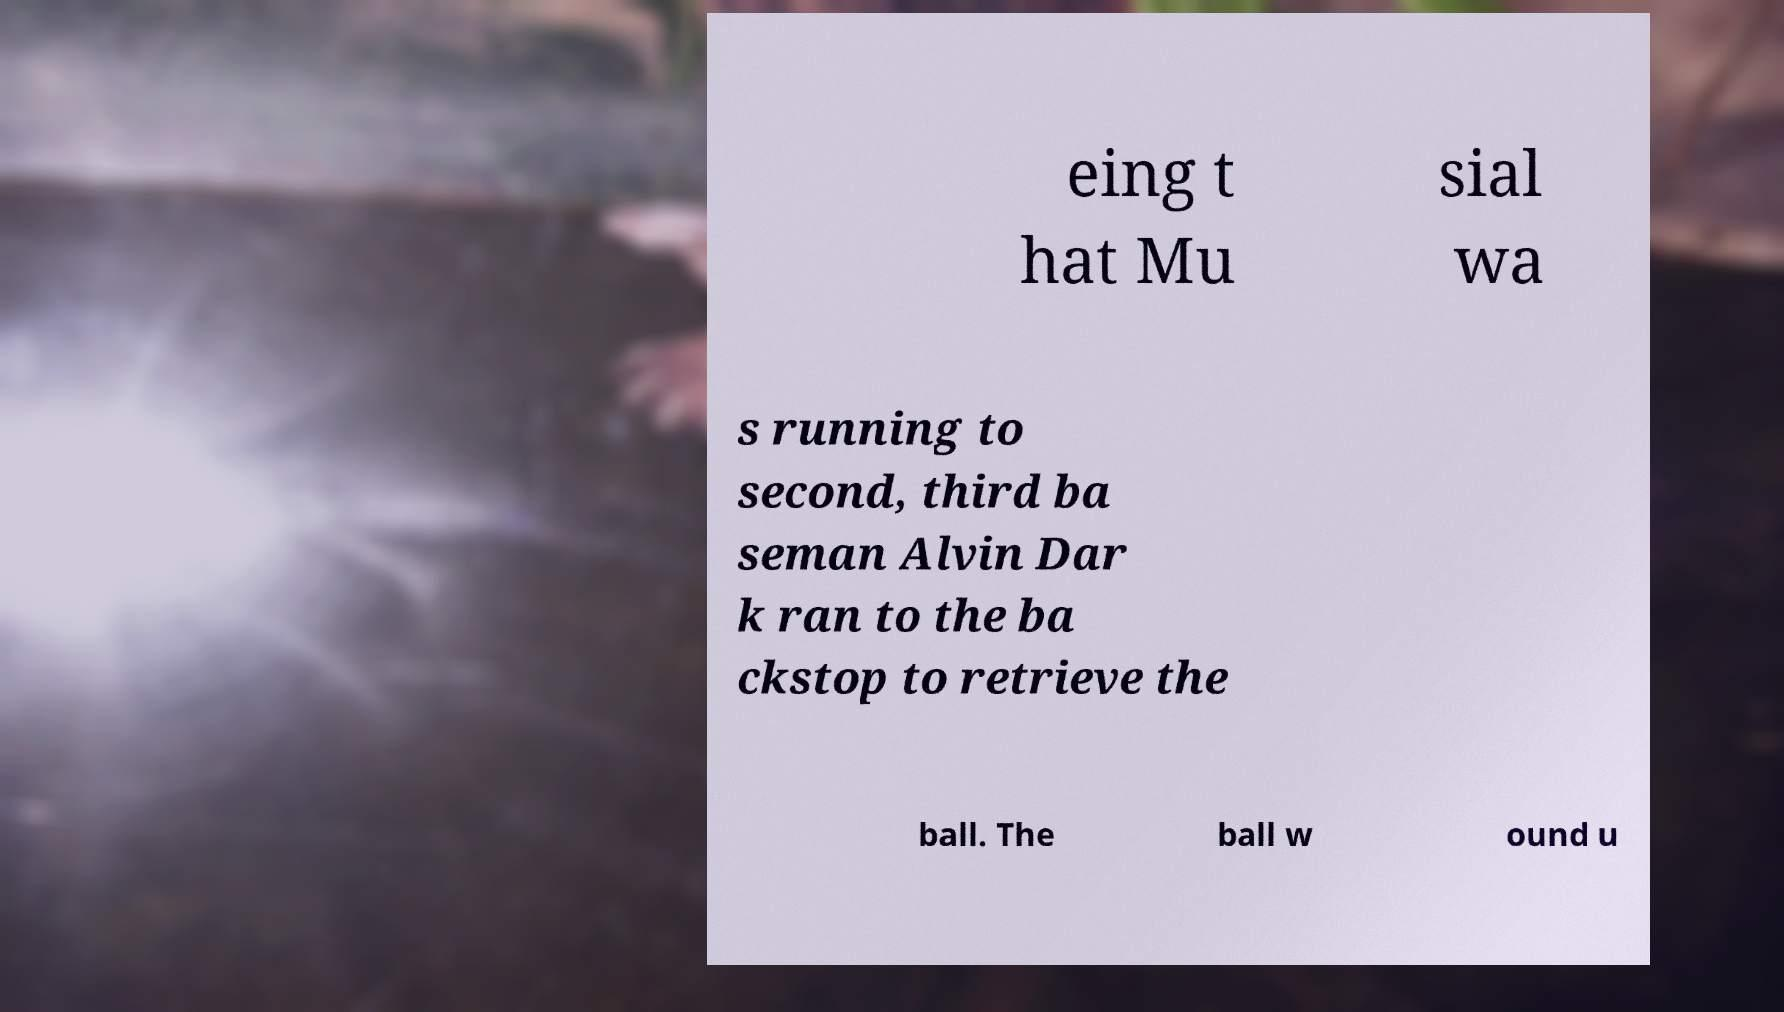There's text embedded in this image that I need extracted. Can you transcribe it verbatim? eing t hat Mu sial wa s running to second, third ba seman Alvin Dar k ran to the ba ckstop to retrieve the ball. The ball w ound u 